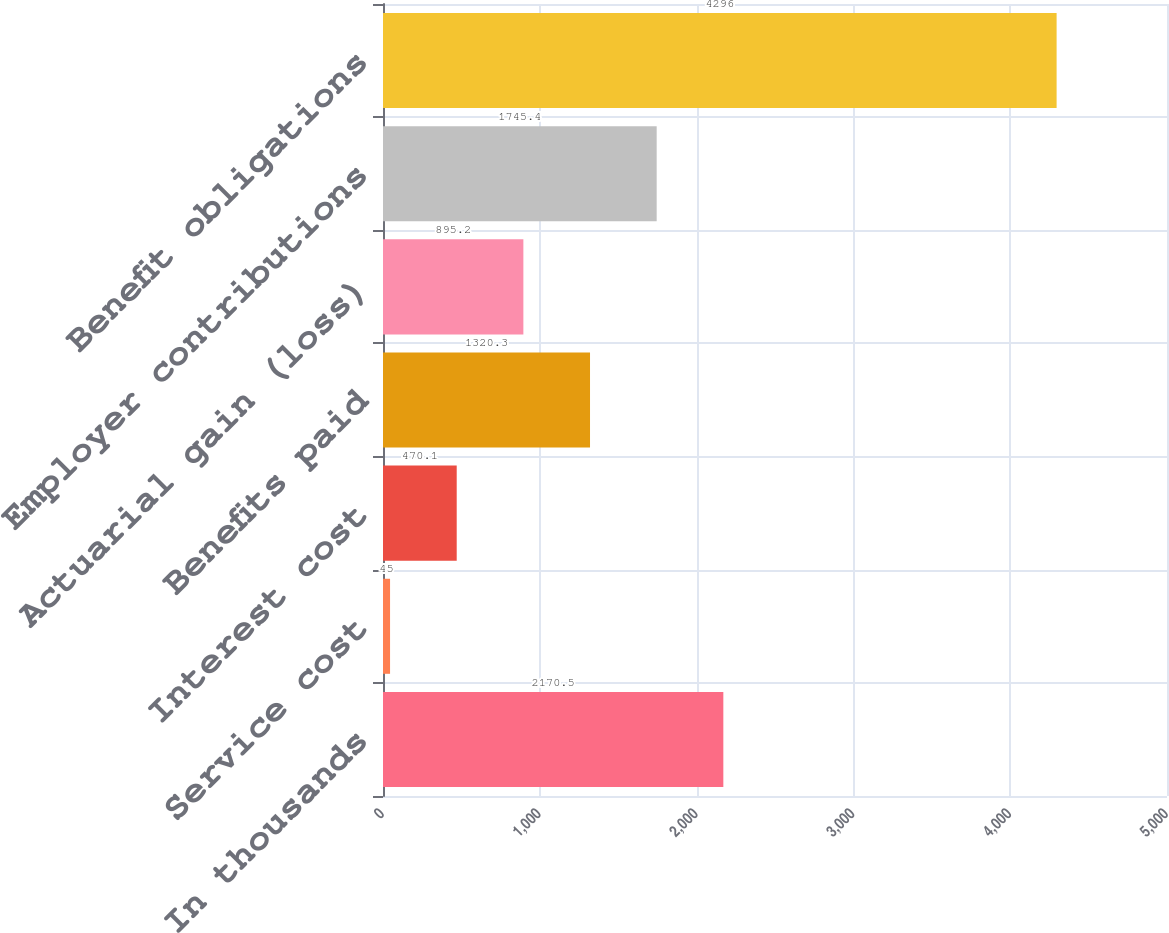Convert chart to OTSL. <chart><loc_0><loc_0><loc_500><loc_500><bar_chart><fcel>In thousands<fcel>Service cost<fcel>Interest cost<fcel>Benefits paid<fcel>Actuarial gain (loss)<fcel>Employer contributions<fcel>Benefit obligations<nl><fcel>2170.5<fcel>45<fcel>470.1<fcel>1320.3<fcel>895.2<fcel>1745.4<fcel>4296<nl></chart> 